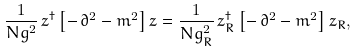<formula> <loc_0><loc_0><loc_500><loc_500>\frac { 1 } { N g ^ { 2 } } \, z ^ { \dagger } \left [ - \, \partial ^ { 2 } - m ^ { 2 } \right ] z = \frac { 1 } { N g _ { R } ^ { 2 } } \, z _ { R } ^ { \dagger } \left [ - \, \partial ^ { 2 } - m ^ { 2 } \right ] z _ { R } ,</formula> 